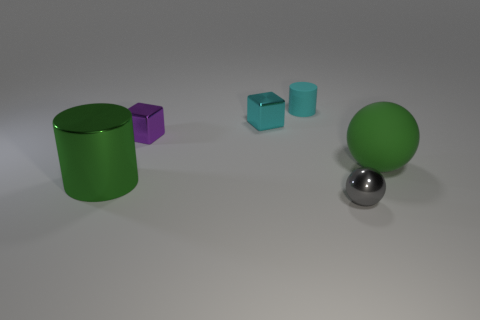Subtract all cyan cylinders. How many cylinders are left? 1 Subtract all purple blocks. How many gray balls are left? 1 Subtract all cyan matte cylinders. Subtract all gray shiny spheres. How many objects are left? 4 Add 3 small gray metal spheres. How many small gray metal spheres are left? 4 Add 4 large cyan rubber blocks. How many large cyan rubber blocks exist? 4 Add 3 cyan cylinders. How many objects exist? 9 Subtract 0 brown cubes. How many objects are left? 6 Subtract all cylinders. How many objects are left? 4 Subtract 1 cubes. How many cubes are left? 1 Subtract all gray balls. Subtract all cyan cylinders. How many balls are left? 1 